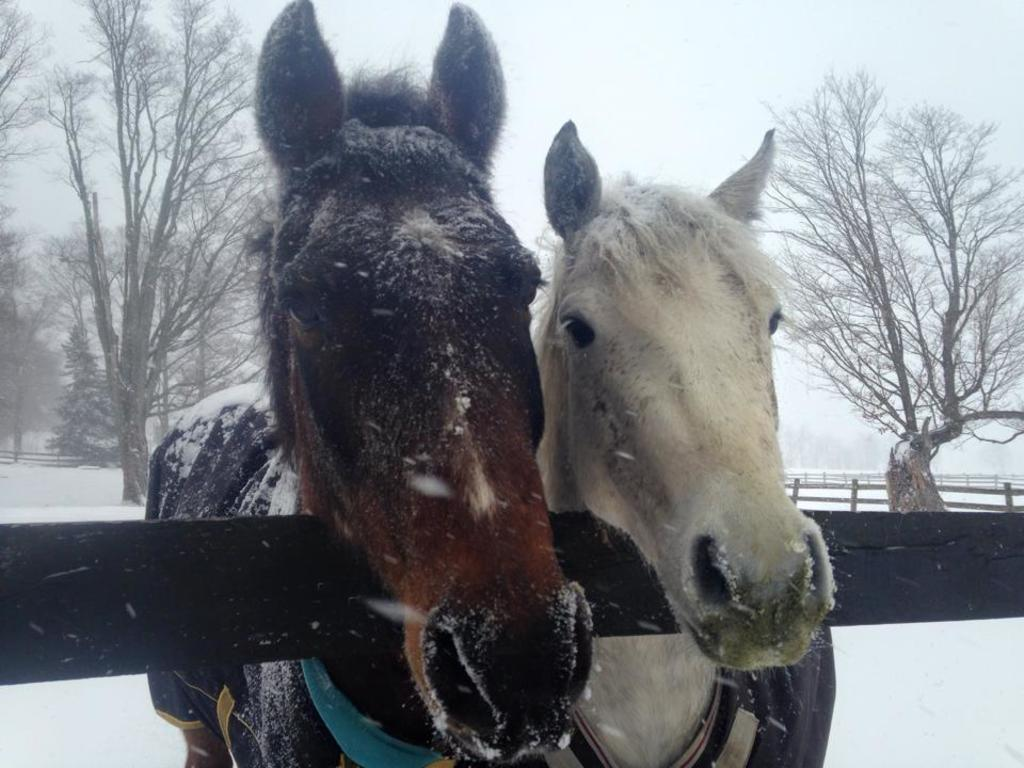What animals are in the center of the image? There are two horses in the center of the image. What can be seen in the background of the image? There is fencing and trees in the background of the image. What is the ground covered with at the bottom of the image? There is snow at the bottom of the image. What type of rake is being used by the horses in the image? There is no rake present in the image; the horses are not using any tools. 